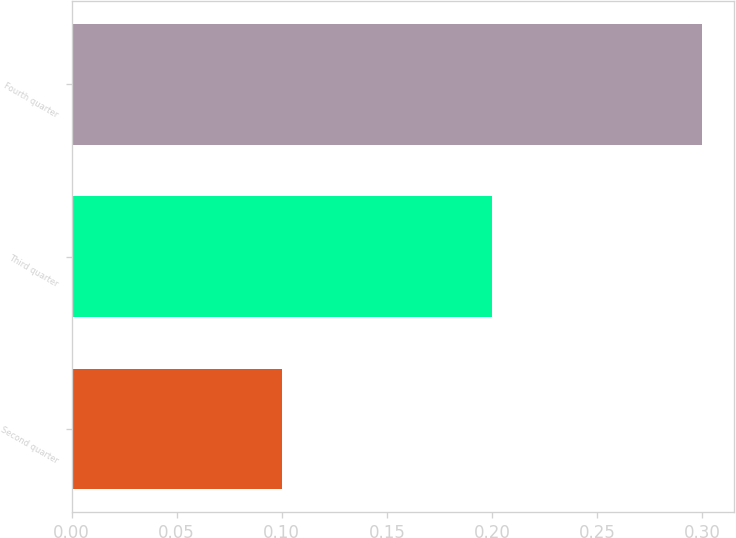Convert chart. <chart><loc_0><loc_0><loc_500><loc_500><bar_chart><fcel>Second quarter<fcel>Third quarter<fcel>Fourth quarter<nl><fcel>0.1<fcel>0.2<fcel>0.3<nl></chart> 